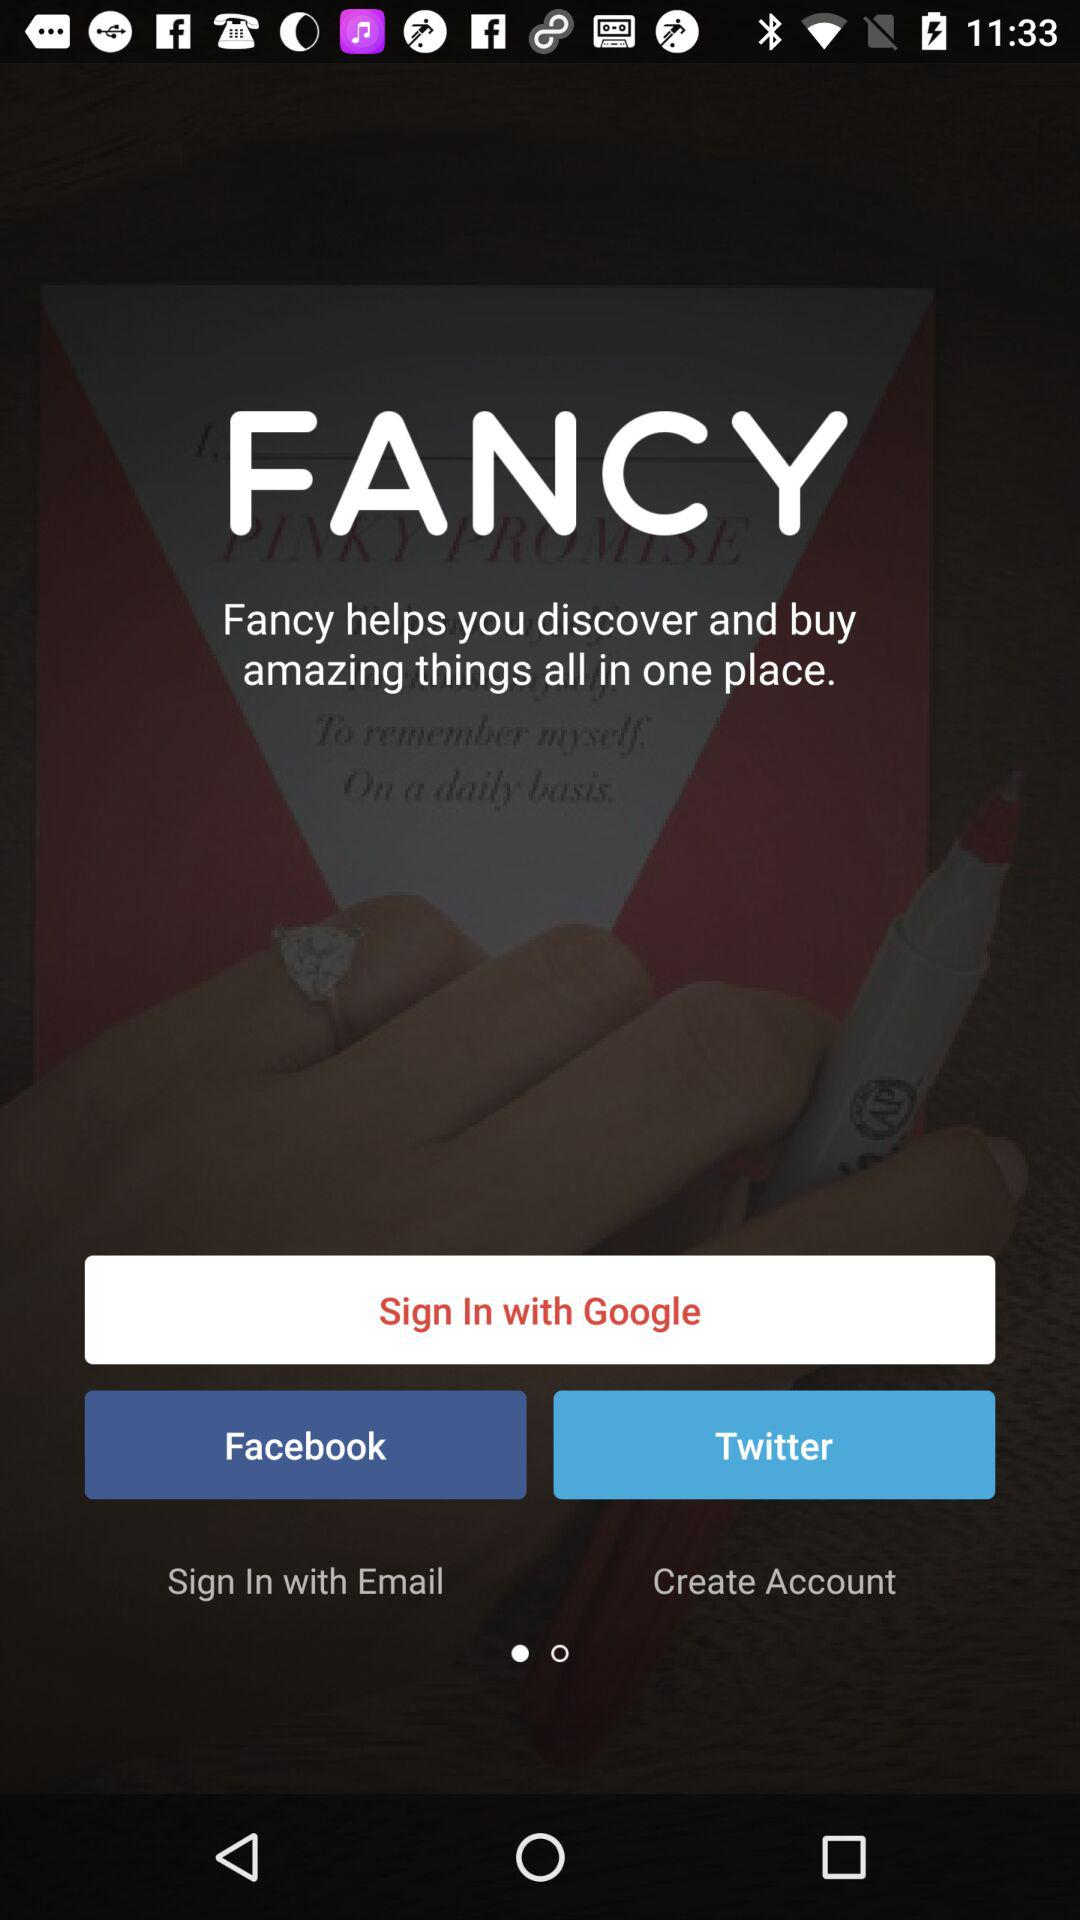What is the app name? The app name is "FANCY". 